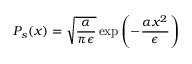<formula> <loc_0><loc_0><loc_500><loc_500>P _ { s } ( x ) = \sqrt { \frac { \alpha } { \pi \epsilon } } \exp \left ( { - \frac { \alpha x ^ { 2 } } { \epsilon } } \right )</formula> 